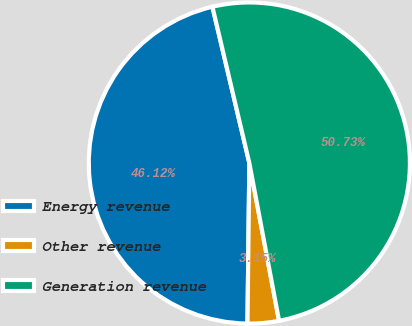<chart> <loc_0><loc_0><loc_500><loc_500><pie_chart><fcel>Energy revenue<fcel>Other revenue<fcel>Generation revenue<nl><fcel>46.12%<fcel>3.15%<fcel>50.73%<nl></chart> 